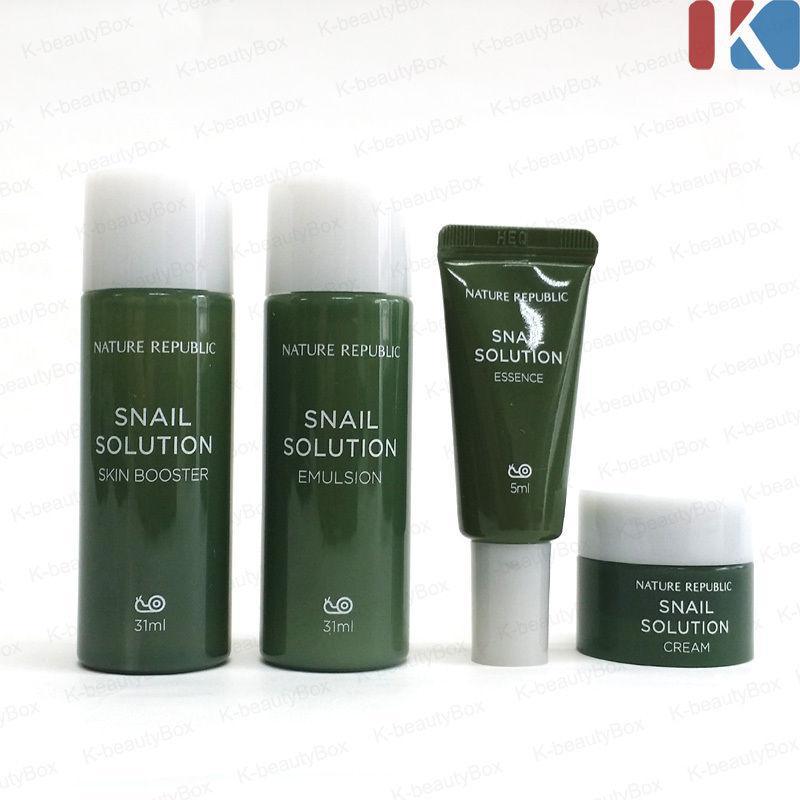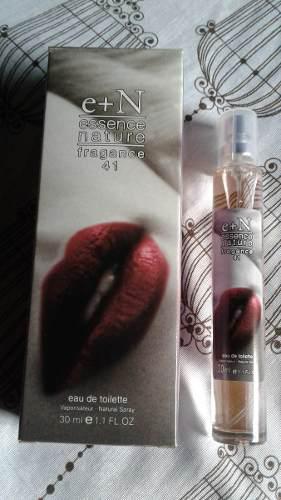The first image is the image on the left, the second image is the image on the right. Given the left and right images, does the statement "There are two long cylindrical perfume bottles next to their packaging box." hold true? Answer yes or no. No. The first image is the image on the left, the second image is the image on the right. For the images shown, is this caption "Two slender spray bottles with clear caps are shown to the right of their boxes." true? Answer yes or no. No. 